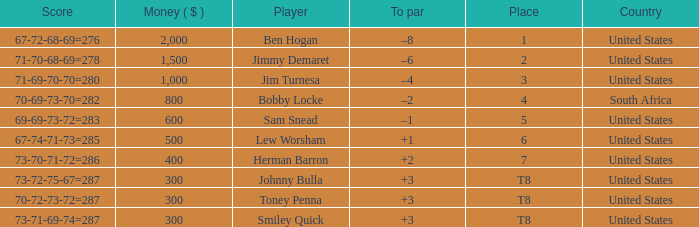How much money does the player in the 5th place have? 600.0. Help me parse the entirety of this table. {'header': ['Score', 'Money ( $ )', 'Player', 'To par', 'Place', 'Country'], 'rows': [['67-72-68-69=276', '2,000', 'Ben Hogan', '–8', '1', 'United States'], ['71-70-68-69=278', '1,500', 'Jimmy Demaret', '–6', '2', 'United States'], ['71-69-70-70=280', '1,000', 'Jim Turnesa', '–4', '3', 'United States'], ['70-69-73-70=282', '800', 'Bobby Locke', '–2', '4', 'South Africa'], ['69-69-73-72=283', '600', 'Sam Snead', '–1', '5', 'United States'], ['67-74-71-73=285', '500', 'Lew Worsham', '+1', '6', 'United States'], ['73-70-71-72=286', '400', 'Herman Barron', '+2', '7', 'United States'], ['73-72-75-67=287', '300', 'Johnny Bulla', '+3', 'T8', 'United States'], ['70-72-73-72=287', '300', 'Toney Penna', '+3', 'T8', 'United States'], ['73-71-69-74=287', '300', 'Smiley Quick', '+3', 'T8', 'United States']]} 